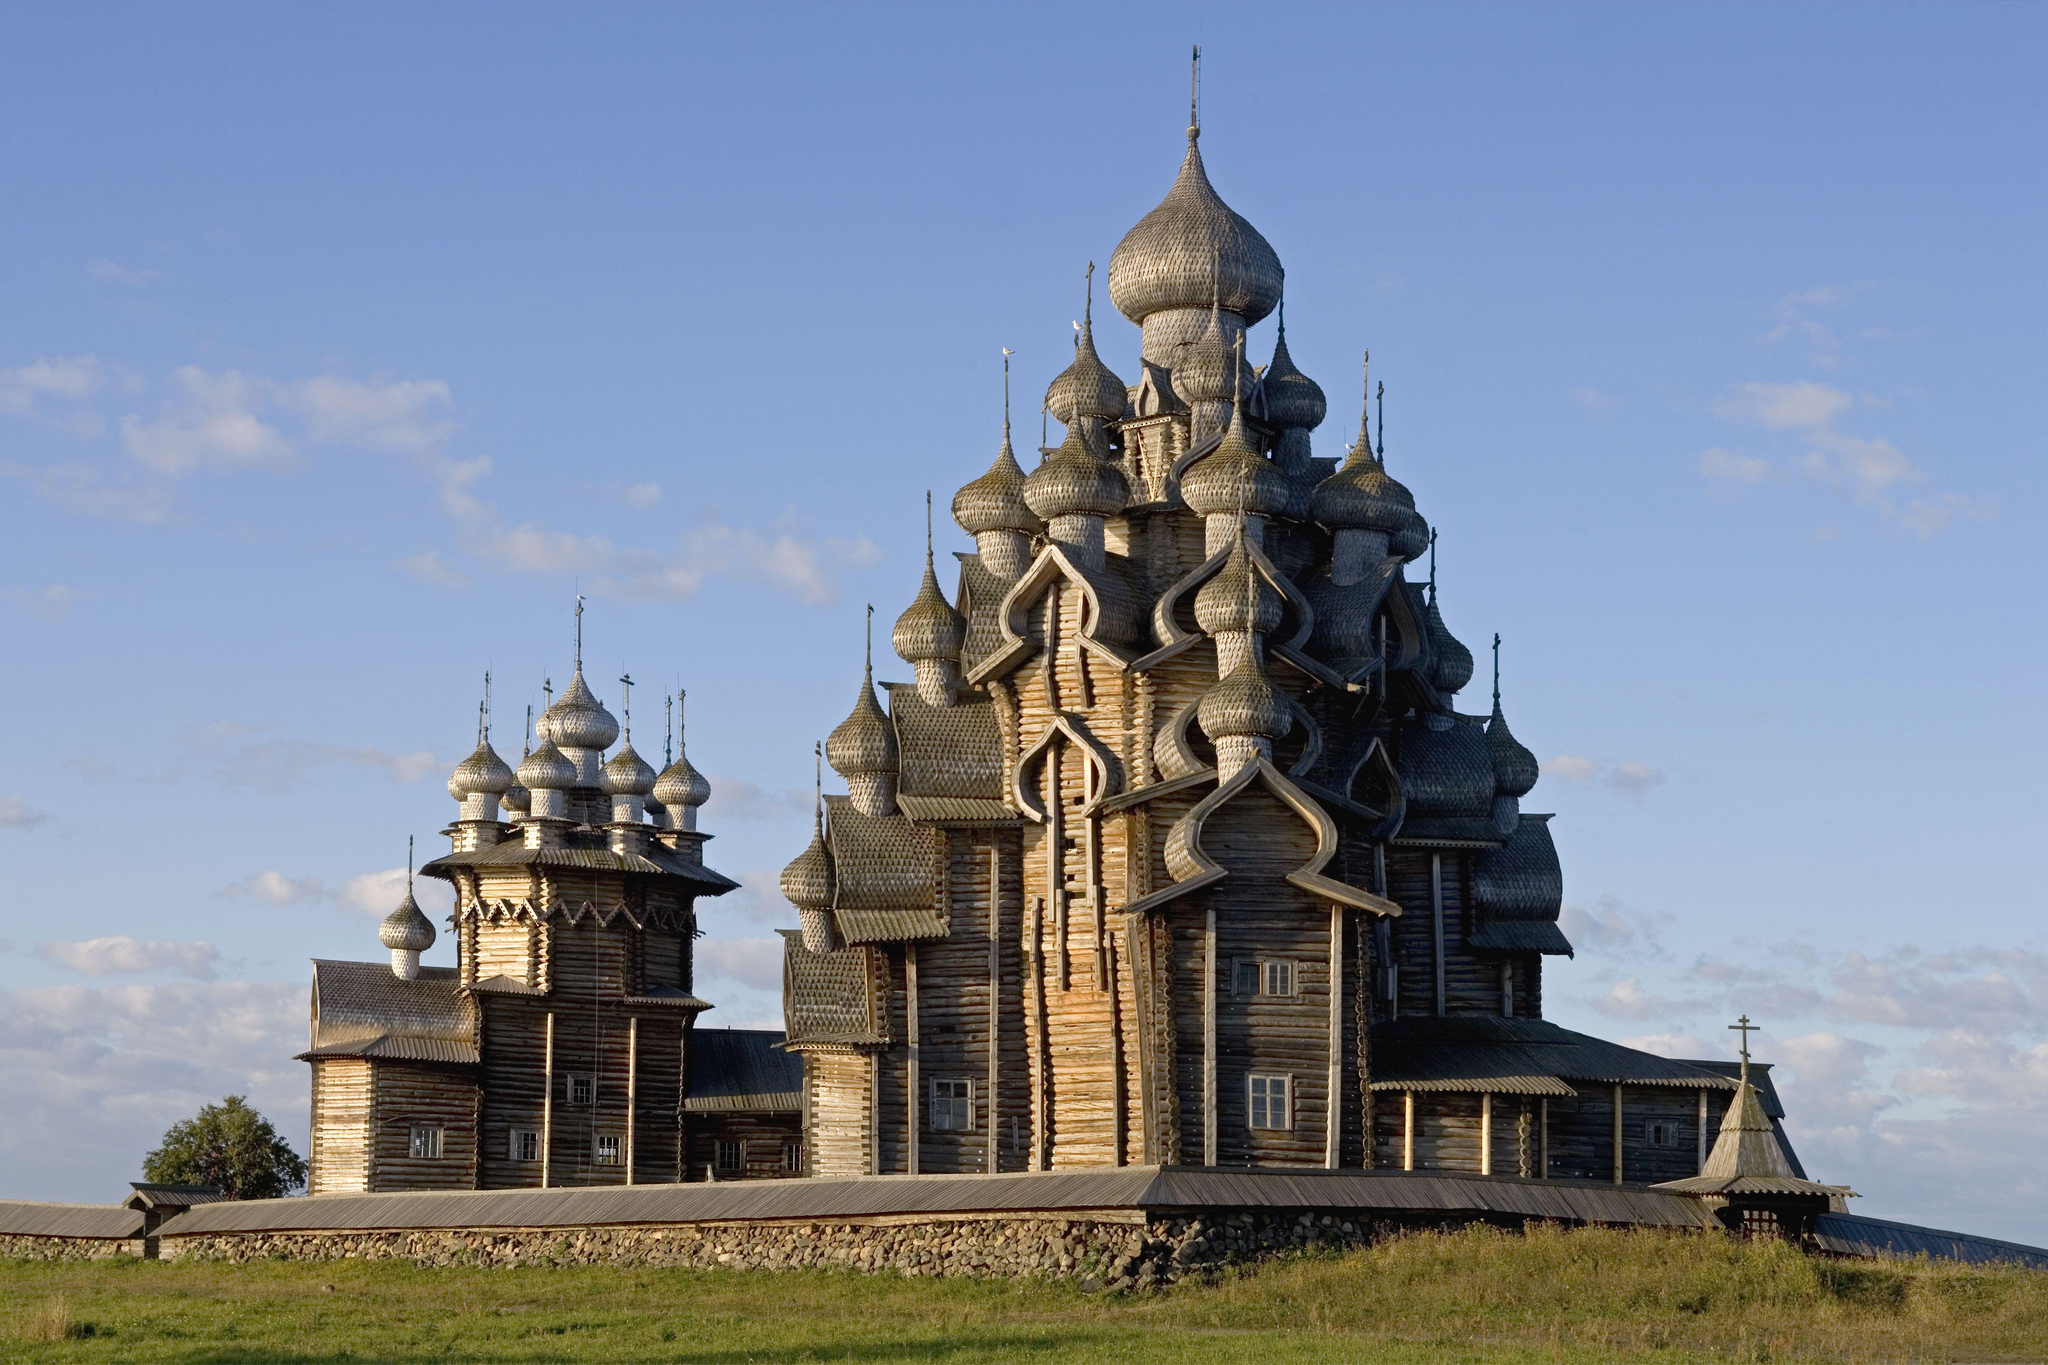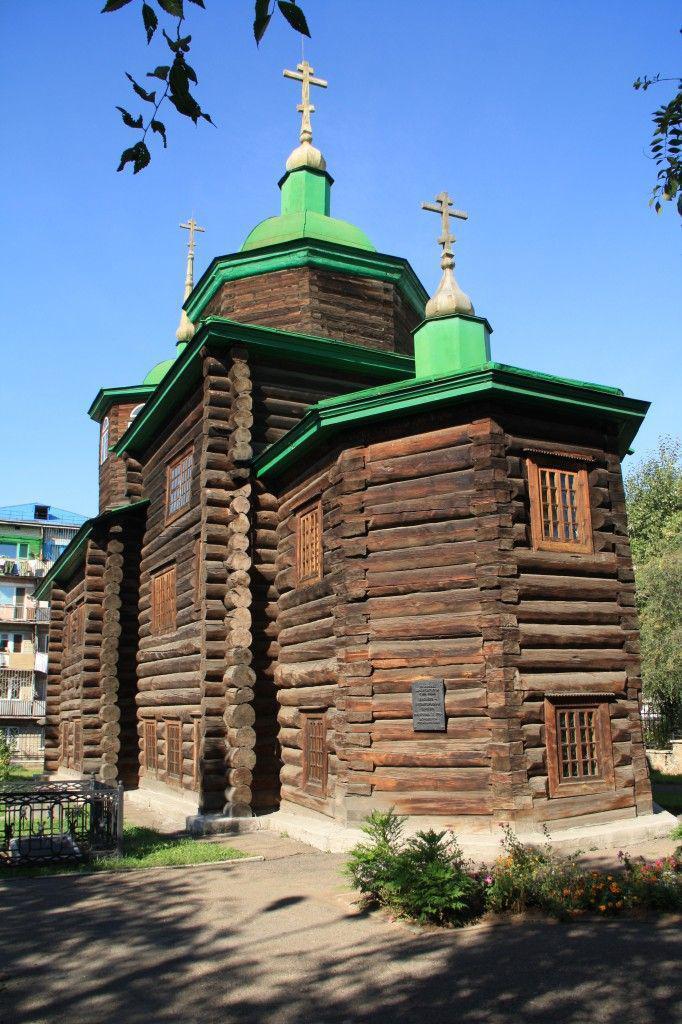The first image is the image on the left, the second image is the image on the right. For the images shown, is this caption "There is a cross atop the building in the image on the left." true? Answer yes or no. No. The first image is the image on the left, the second image is the image on the right. Analyze the images presented: Is the assertion "In one image, the roof features green shapes topped with crosses." valid? Answer yes or no. Yes. 